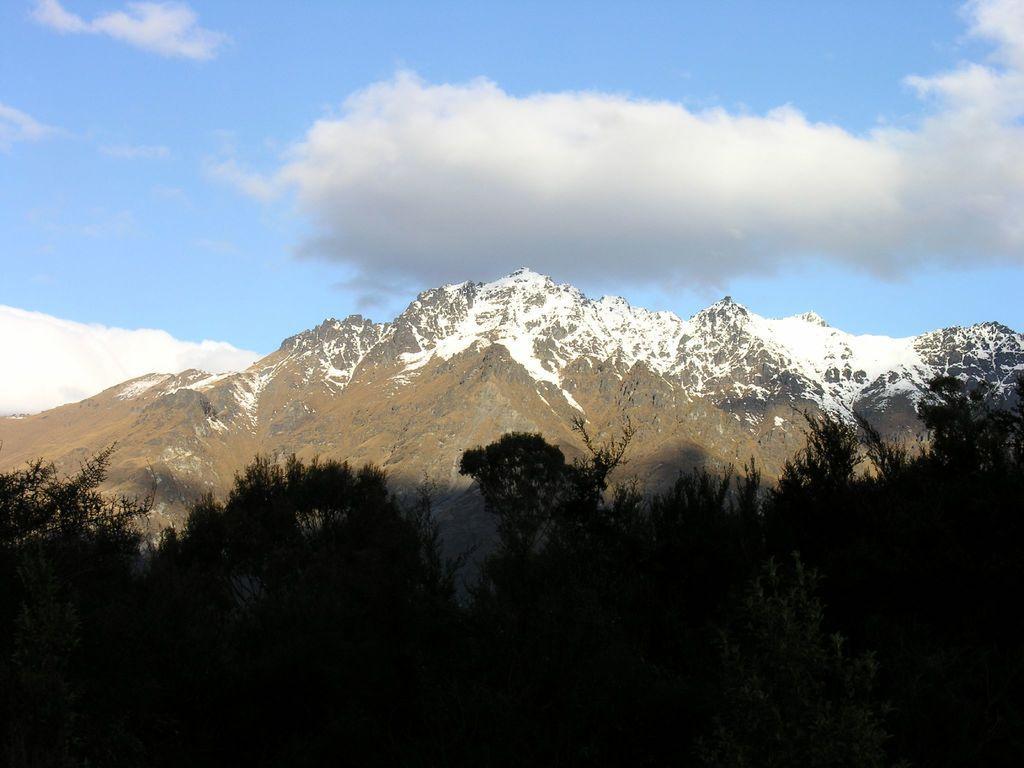Could you give a brief overview of what you see in this image? In this image, we can see trees, mountain covered with snow. At the top, there are clouds in the sky. 